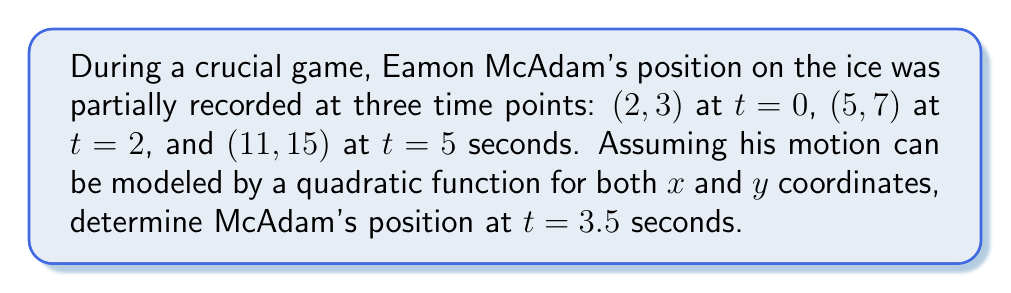Teach me how to tackle this problem. Let's approach this step-by-step:

1) We need to find quadratic functions for both $x$ and $y$ coordinates in the form:
   $x(t) = at^2 + bt + c$
   $y(t) = dt^2 + et + f$

2) For $x(t)$, we have three equations:
   $2 = c$
   $5 = 4a + 2b + c$
   $11 = 25a + 5b + c$

3) Solving this system:
   $c = 2$
   $3 = 4a + 2b$
   $9 = 25a + 5b$

4) Subtracting 5 times the second equation from the third:
   $9 - 15 = 25a + 5b - (20a + 10b)$
   $-6 = 5a - 5b$
   $b = a + \frac{6}{5}$

5) Substituting back:
   $3 = 4a + 2(a + \frac{6}{5}) = 6a + \frac{12}{5}$
   $a = \frac{3}{10}$, $b = \frac{9}{5}$

6) Therefore, $x(t) = \frac{3}{10}t^2 + \frac{9}{5}t + 2$

7) Similarly for $y(t)$, we get:
   $y(t) = \frac{1}{2}t^2 + 2t + 3$

8) At $t=3.5$:
   $x(3.5) = \frac{3}{10}(3.5)^2 + \frac{9}{5}(3.5) + 2 = 8.5625$
   $y(3.5) = \frac{1}{2}(3.5)^2 + 2(3.5) + 3 = 12.625$
Answer: $(8.5625, 12.625)$ 